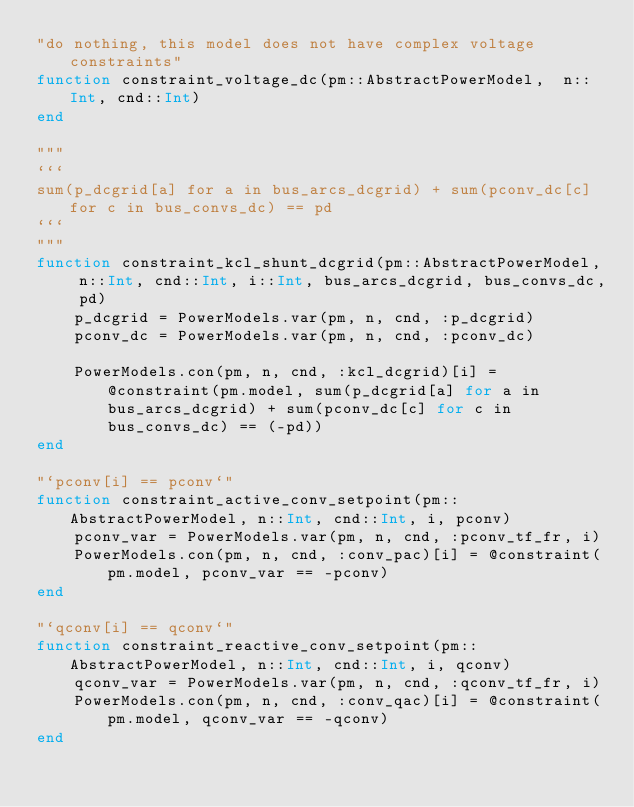Convert code to text. <code><loc_0><loc_0><loc_500><loc_500><_Julia_>"do nothing, this model does not have complex voltage constraints"
function constraint_voltage_dc(pm::AbstractPowerModel,  n::Int, cnd::Int)
end

"""
```
sum(p_dcgrid[a] for a in bus_arcs_dcgrid) + sum(pconv_dc[c] for c in bus_convs_dc) == pd
```
"""
function constraint_kcl_shunt_dcgrid(pm::AbstractPowerModel, n::Int, cnd::Int, i::Int, bus_arcs_dcgrid, bus_convs_dc, pd)
    p_dcgrid = PowerModels.var(pm, n, cnd, :p_dcgrid)
    pconv_dc = PowerModels.var(pm, n, cnd, :pconv_dc)

    PowerModels.con(pm, n, cnd, :kcl_dcgrid)[i] = @constraint(pm.model, sum(p_dcgrid[a] for a in bus_arcs_dcgrid) + sum(pconv_dc[c] for c in bus_convs_dc) == (-pd))
end

"`pconv[i] == pconv`"
function constraint_active_conv_setpoint(pm::AbstractPowerModel, n::Int, cnd::Int, i, pconv)
    pconv_var = PowerModels.var(pm, n, cnd, :pconv_tf_fr, i)
    PowerModels.con(pm, n, cnd, :conv_pac)[i] = @constraint(pm.model, pconv_var == -pconv)
end

"`qconv[i] == qconv`"
function constraint_reactive_conv_setpoint(pm::AbstractPowerModel, n::Int, cnd::Int, i, qconv)
    qconv_var = PowerModels.var(pm, n, cnd, :qconv_tf_fr, i)
    PowerModels.con(pm, n, cnd, :conv_qac)[i] = @constraint(pm.model, qconv_var == -qconv)
end
</code> 